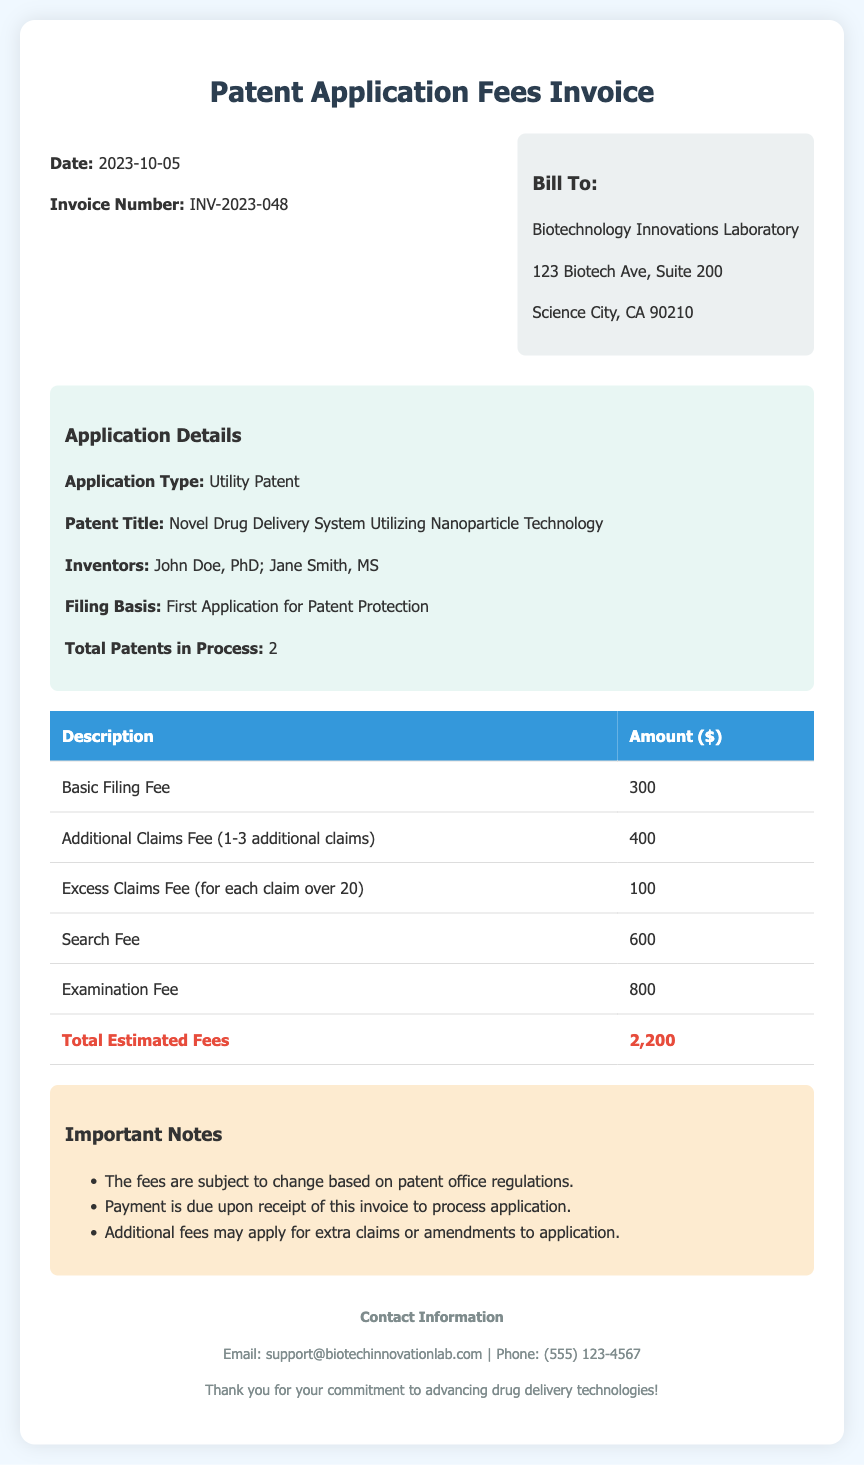What is the invoice number? The invoice number is indicated in the document as INV-2023-048.
Answer: INV-2023-048 What is the date of the invoice? The date of the invoice is provided at the top of the document, which is 2023-10-05.
Answer: 2023-10-05 Who are the inventors listed in the application? The inventors are detailed in the application section, which lists John Doe, PhD, and Jane Smith, MS.
Answer: John Doe, PhD; Jane Smith, MS What is the total estimated fees for the patent application? The total estimated fees are shown in the table, summing all charges, which is $2200.
Answer: 2,200 What kind of patent application is this? The type of application is listed in the details section, specifically as a Utility Patent.
Answer: Utility Patent How much is the basic filing fee? The basic filing fee is detailed in the table as $300.
Answer: 300 What does the term "Excess Claims Fee" refer to? The term "Excess Claims Fee" is defined in the document for each claim over the limit specified, with an amount of $100 mentioned in the table.
Answer: for each claim over 20 Is payment due upon receipt of the invoice? The notes section states that payment is due upon receipt of this invoice, indicating a requirement.
Answer: Yes 